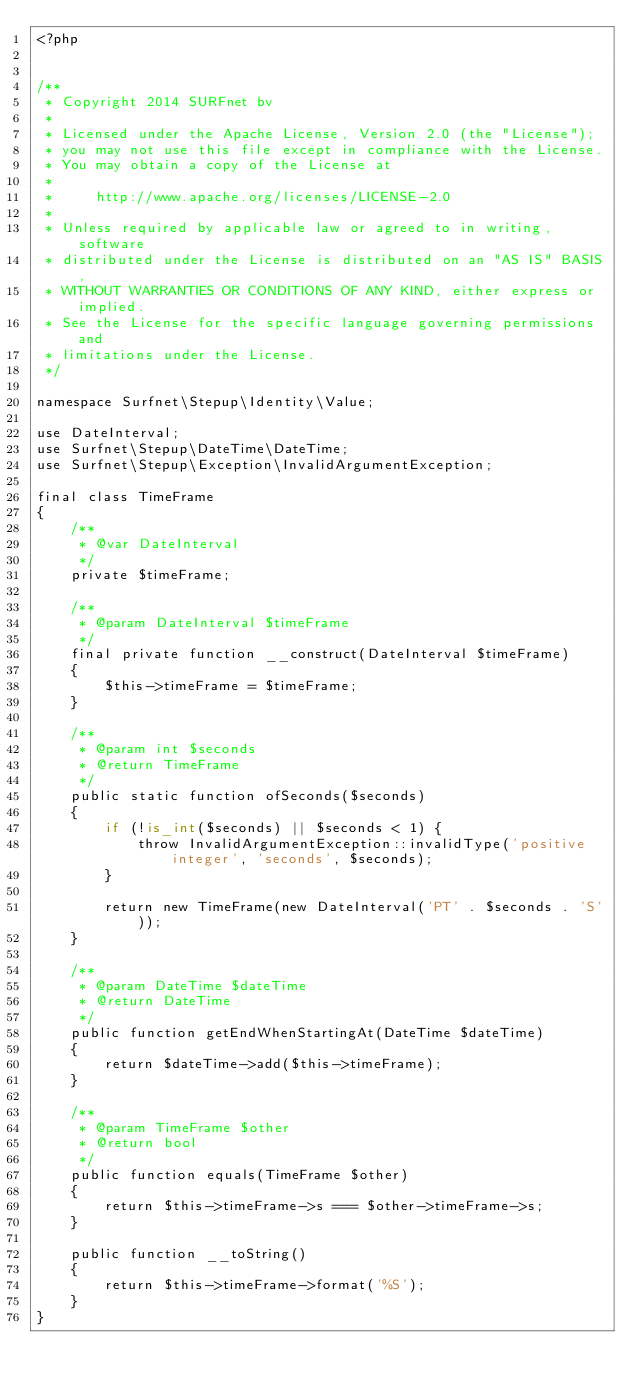Convert code to text. <code><loc_0><loc_0><loc_500><loc_500><_PHP_><?php


/**
 * Copyright 2014 SURFnet bv
 *
 * Licensed under the Apache License, Version 2.0 (the "License");
 * you may not use this file except in compliance with the License.
 * You may obtain a copy of the License at
 *
 *     http://www.apache.org/licenses/LICENSE-2.0
 *
 * Unless required by applicable law or agreed to in writing, software
 * distributed under the License is distributed on an "AS IS" BASIS,
 * WITHOUT WARRANTIES OR CONDITIONS OF ANY KIND, either express or implied.
 * See the License for the specific language governing permissions and
 * limitations under the License.
 */

namespace Surfnet\Stepup\Identity\Value;

use DateInterval;
use Surfnet\Stepup\DateTime\DateTime;
use Surfnet\Stepup\Exception\InvalidArgumentException;

final class TimeFrame
{
    /**
     * @var DateInterval
     */
    private $timeFrame;

    /**
     * @param DateInterval $timeFrame
     */
    final private function __construct(DateInterval $timeFrame)
    {
        $this->timeFrame = $timeFrame;
    }

    /**
     * @param int $seconds
     * @return TimeFrame
     */
    public static function ofSeconds($seconds)
    {
        if (!is_int($seconds) || $seconds < 1) {
            throw InvalidArgumentException::invalidType('positive integer', 'seconds', $seconds);
        }

        return new TimeFrame(new DateInterval('PT' . $seconds . 'S'));
    }

    /**
     * @param DateTime $dateTime
     * @return DateTime
     */
    public function getEndWhenStartingAt(DateTime $dateTime)
    {
        return $dateTime->add($this->timeFrame);
    }

    /**
     * @param TimeFrame $other
     * @return bool
     */
    public function equals(TimeFrame $other)
    {
        return $this->timeFrame->s === $other->timeFrame->s;
    }

    public function __toString()
    {
        return $this->timeFrame->format('%S');
    }
}
</code> 